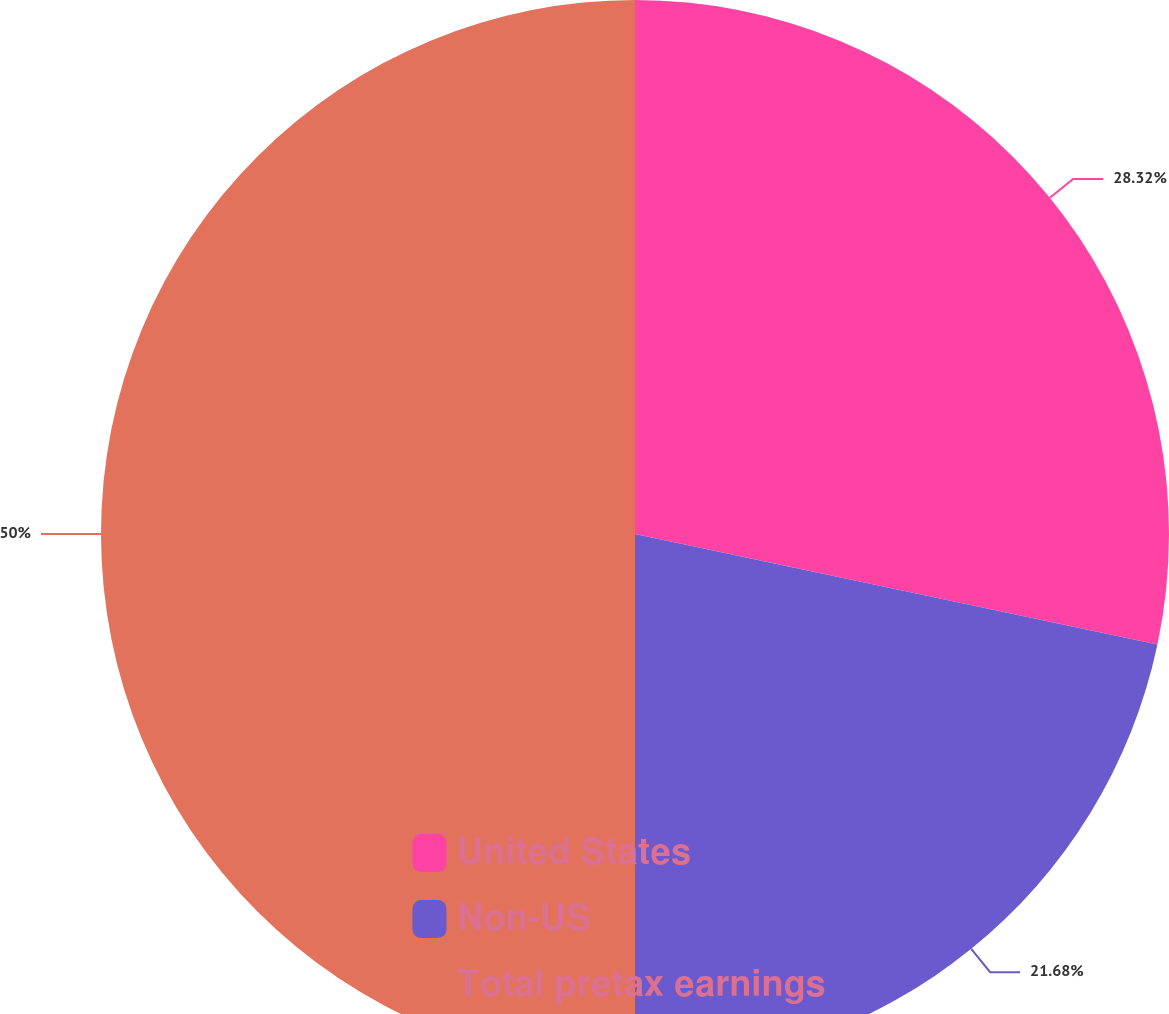Convert chart to OTSL. <chart><loc_0><loc_0><loc_500><loc_500><pie_chart><fcel>United States<fcel>Non-US<fcel>Total pretax earnings<nl><fcel>28.32%<fcel>21.68%<fcel>50.0%<nl></chart> 